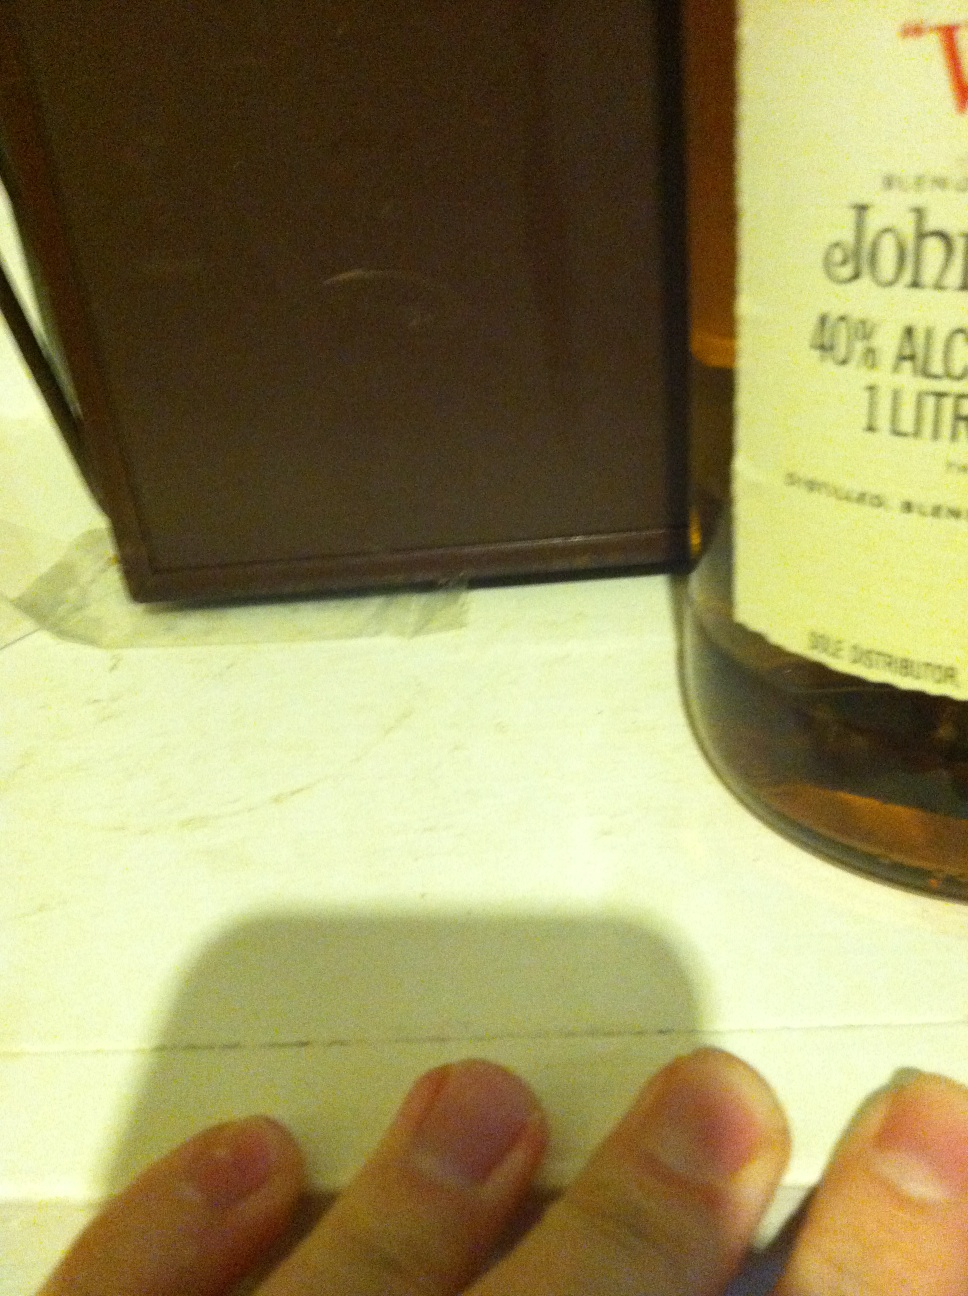What is in this bottle? The bottle contains whisky, specifically a brand with an alcohol content of 40%. The label appears to indicate it's a blended whisky with a volume of 1 liter. 